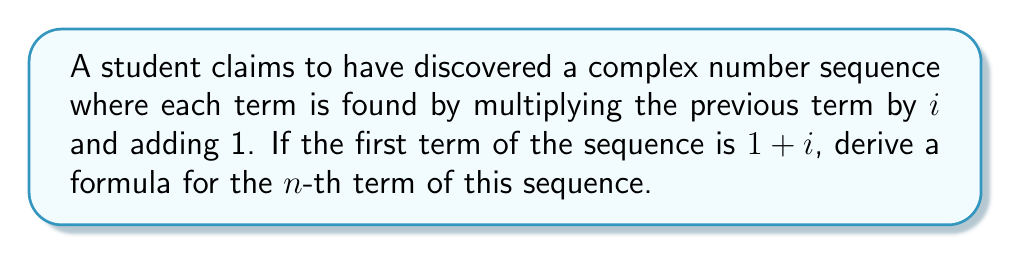Teach me how to tackle this problem. Let's approach this step-by-step:

1) Let's denote the $n$-th term of the sequence as $a_n$.

2) We're given that $a_1 = 1+i$.

3) The recurrence relation for this sequence is:
   $a_{n+1} = ia_n + 1$

4) Let's calculate the first few terms to observe the pattern:
   $a_1 = 1+i$
   $a_2 = i(1+i) + 1 = i+i^2+1 = i-1+1 = i$
   $a_3 = i(i) + 1 = i^2 + 1 = -1 + 1 = 0$
   $a_4 = i(0) + 1 = 1$
   $a_5 = i(1) + 1 = i + 1$

5) We can see that the sequence repeats every 4 terms.

6) Let's express this mathematically:
   For any positive integer $k$,
   $a_{4k+1} = 1+i$
   $a_{4k+2} = i$
   $a_{4k+3} = 0$
   $a_{4k+4} = 1$

7) We can combine these into a single formula using the modulo operation:
   $$a_n = \begin{cases}
   1+i & \text{if } n \equiv 1 \pmod{4} \\
   i & \text{if } n \equiv 2 \pmod{4} \\
   0 & \text{if } n \equiv 3 \pmod{4} \\
   1 & \text{if } n \equiv 0 \pmod{4}
   \end{cases}$$

This formula gives the $n$-th term of the sequence for any positive integer $n$.
Answer: $$a_n = \begin{cases}
1+i & \text{if } n \equiv 1 \pmod{4} \\
i & \text{if } n \equiv 2 \pmod{4} \\
0 & \text{if } n \equiv 3 \pmod{4} \\
1 & \text{if } n \equiv 0 \pmod{4}
\end{cases}$$ 